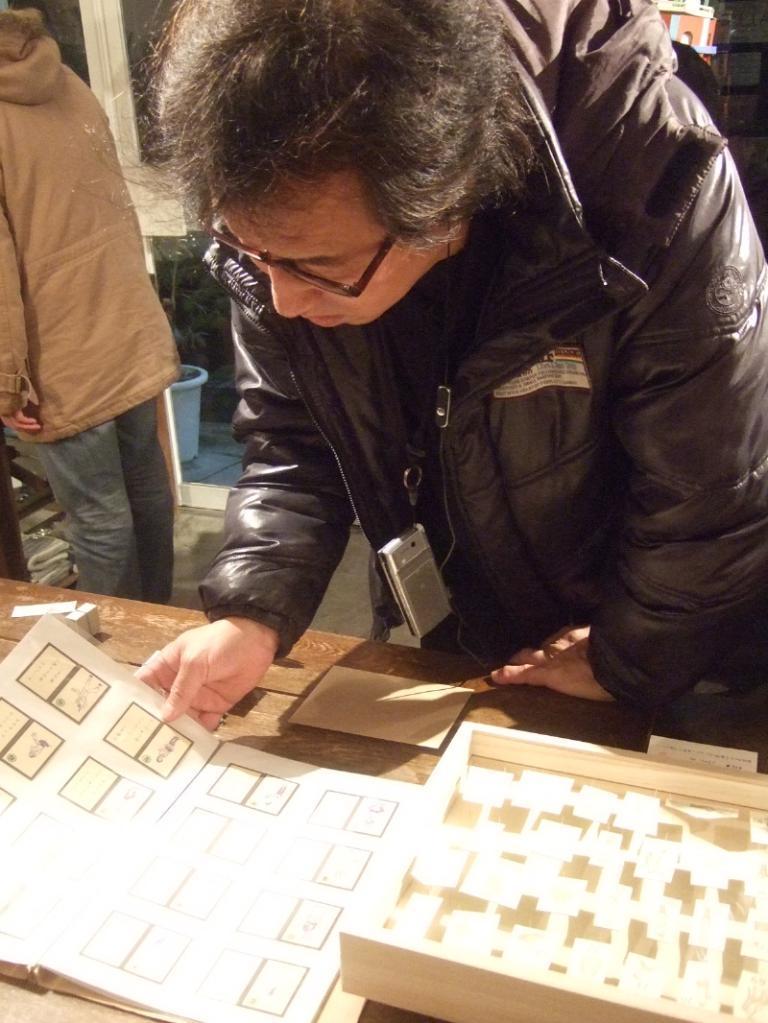Can you describe this image briefly? In this picture there is a man standing and holding the book and there are objects on the table. At the back there is a person standing at the table. There is a bucket and there are plants behind the door. At the bottom there is a floor. 